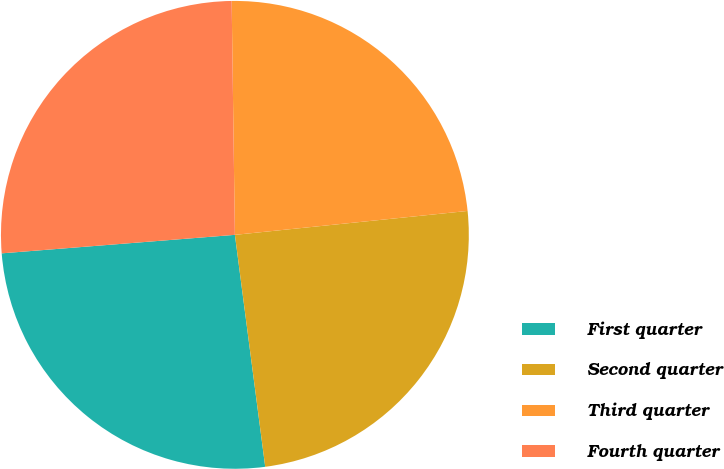Convert chart to OTSL. <chart><loc_0><loc_0><loc_500><loc_500><pie_chart><fcel>First quarter<fcel>Second quarter<fcel>Third quarter<fcel>Fourth quarter<nl><fcel>25.81%<fcel>24.56%<fcel>23.59%<fcel>26.04%<nl></chart> 